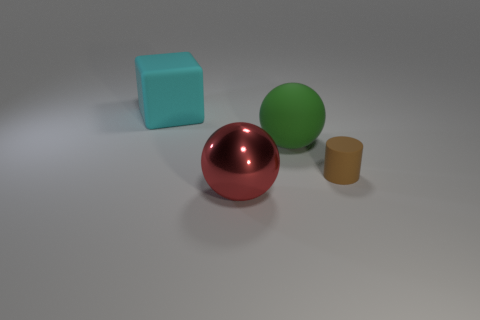Add 2 matte spheres. How many objects exist? 6 Subtract all cylinders. How many objects are left? 3 Add 4 cyan blocks. How many cyan blocks are left? 5 Add 3 small brown blocks. How many small brown blocks exist? 3 Subtract 1 cyan blocks. How many objects are left? 3 Subtract all big red balls. Subtract all brown rubber cylinders. How many objects are left? 2 